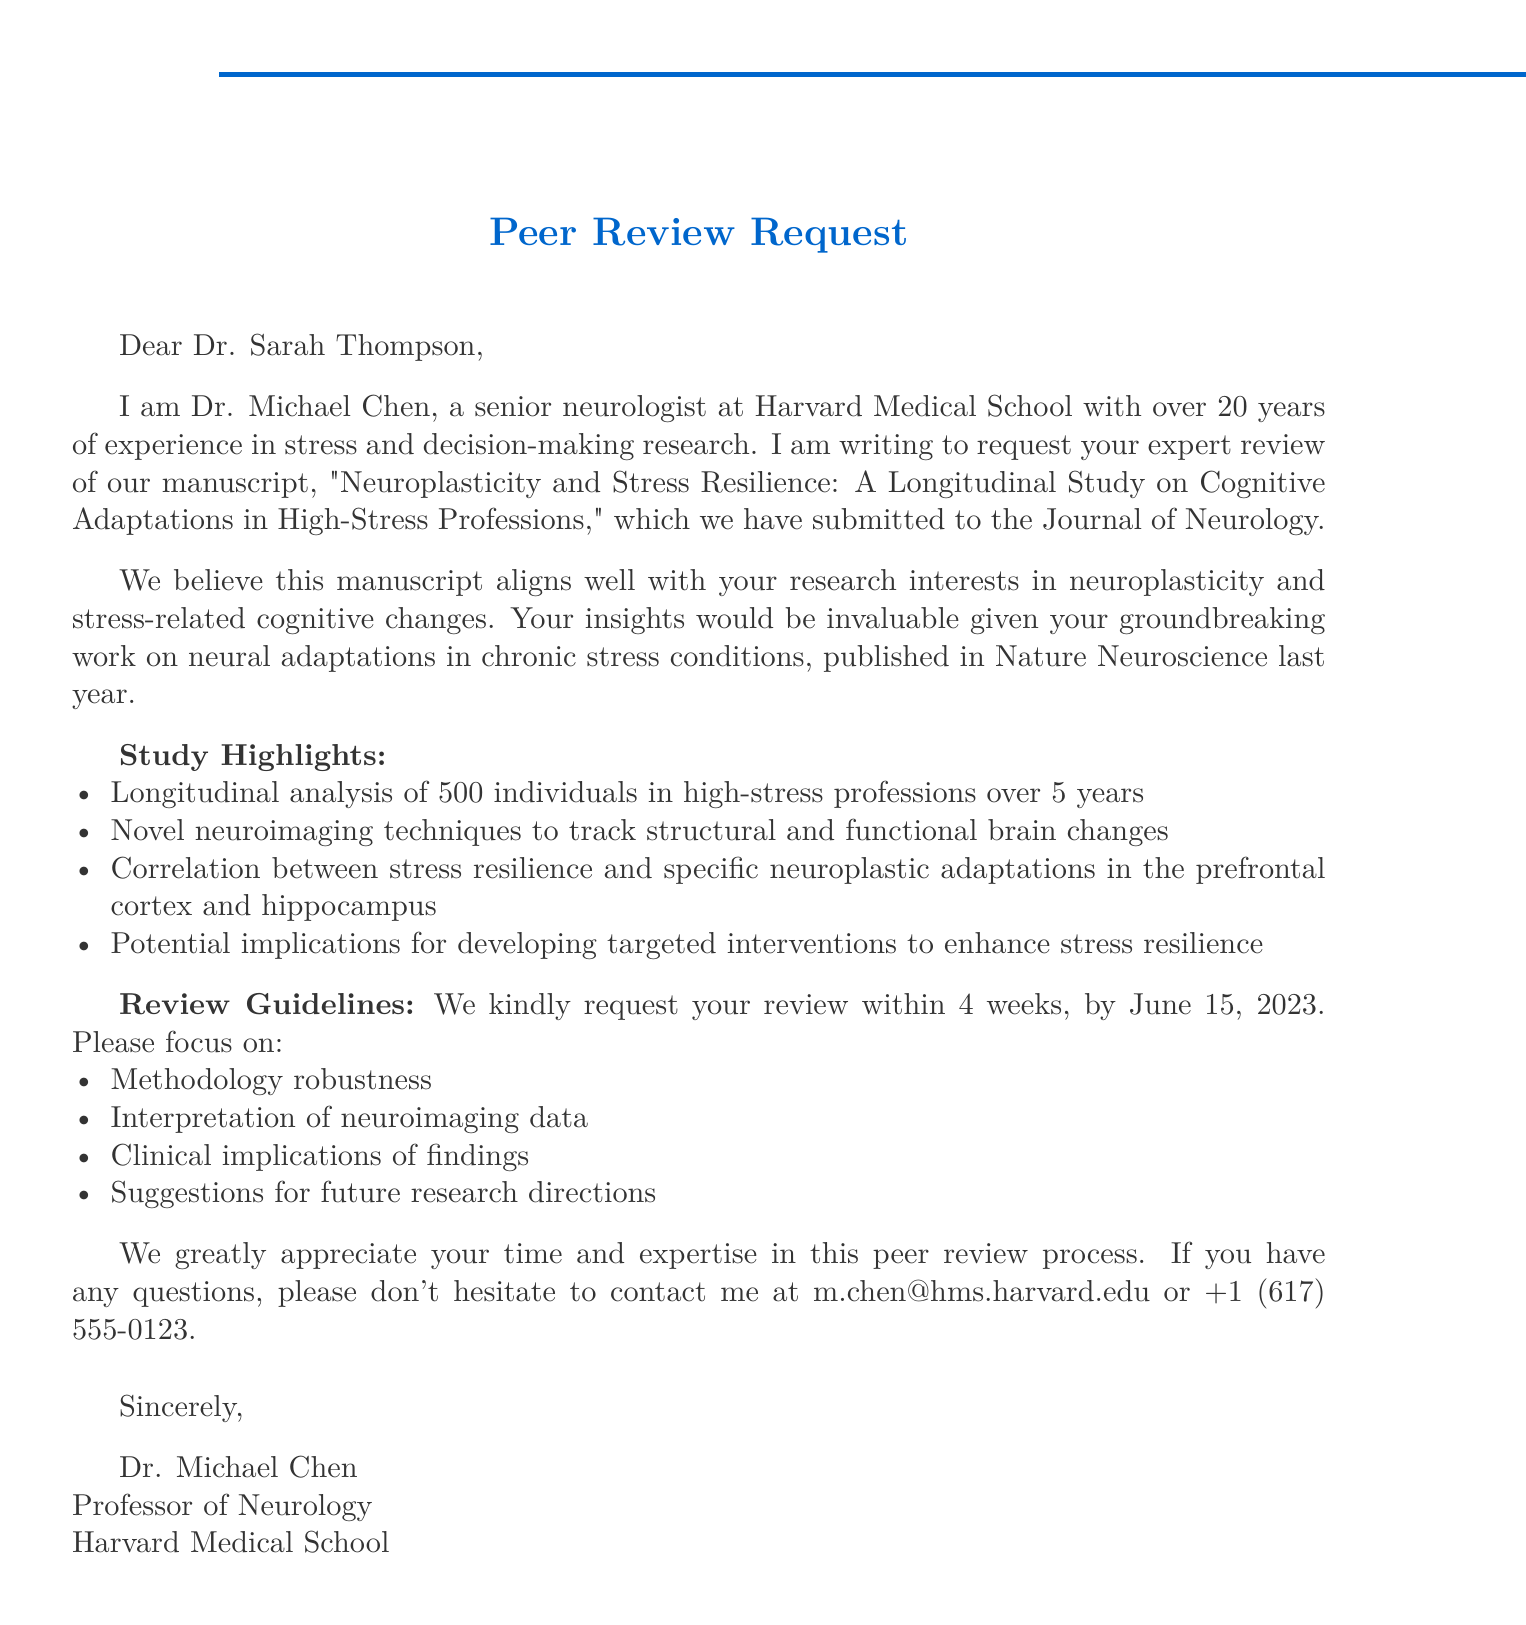What is the title of the manuscript? The title of the manuscript is explicitly stated in the document.
Answer: Neuroplasticity and Stress Resilience: A Longitudinal Study on Cognitive Adaptations in High-Stress Professions Who is the sender of the email? The sender of the email is mentioned in the salutation.
Answer: Dr. Michael Chen What is the name of the journal? The name of the journal is specified in the introductory section of the document.
Answer: Journal of Neurology What is the deadline for the review? The deadline for the review is given in the review guidelines section.
Answer: June 15, 2023 How many individuals were studied in the research? The number of individuals studied is highlighted in the study highlights section.
Answer: 500 individuals What specific brain regions are mentioned in correlation with stress resilience? The document specifies brain regions in the study highlights.
Answer: Prefrontal cortex and hippocampus Why does Dr. Chen value Dr. Thompson's insights? Dr. Chen appreciates Dr. Thompson's expertise in a specific area, mentioned in the document.
Answer: Groundbreaking work on neural adaptations in chronic stress conditions What focus areas are requested for the review? The document cites specific focus areas for the review in the guidelines.
Answer: Methodology robustness, Interpretation of neuroimaging data, Clinical implications of findings, Suggestions for future research directions 